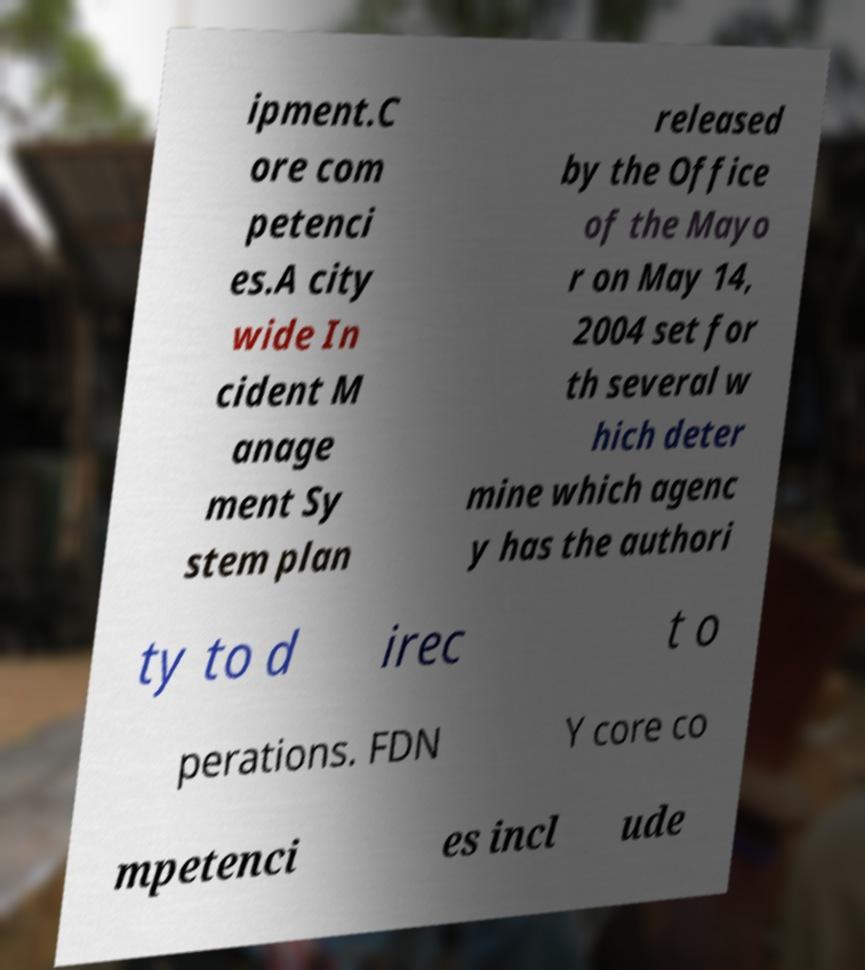Please read and relay the text visible in this image. What does it say? ipment.C ore com petenci es.A city wide In cident M anage ment Sy stem plan released by the Office of the Mayo r on May 14, 2004 set for th several w hich deter mine which agenc y has the authori ty to d irec t o perations. FDN Y core co mpetenci es incl ude 